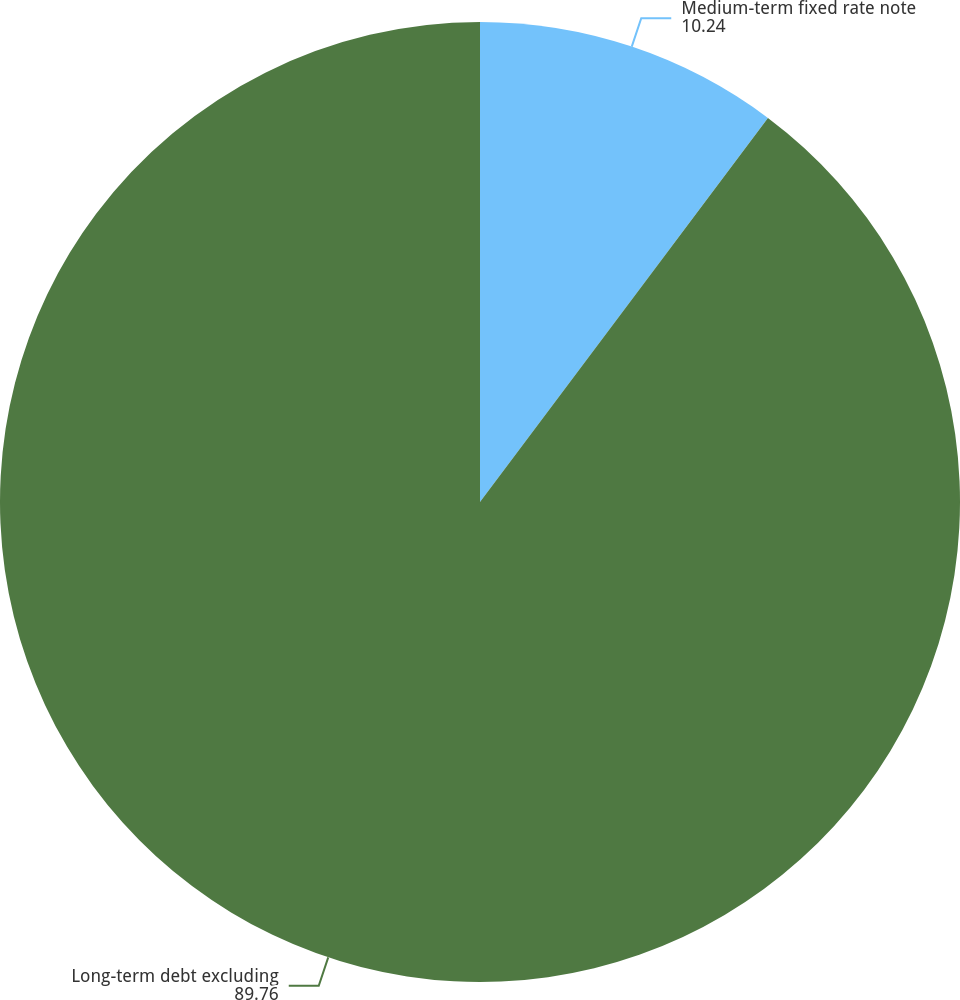Convert chart to OTSL. <chart><loc_0><loc_0><loc_500><loc_500><pie_chart><fcel>Medium-term fixed rate note<fcel>Long-term debt excluding<nl><fcel>10.24%<fcel>89.76%<nl></chart> 